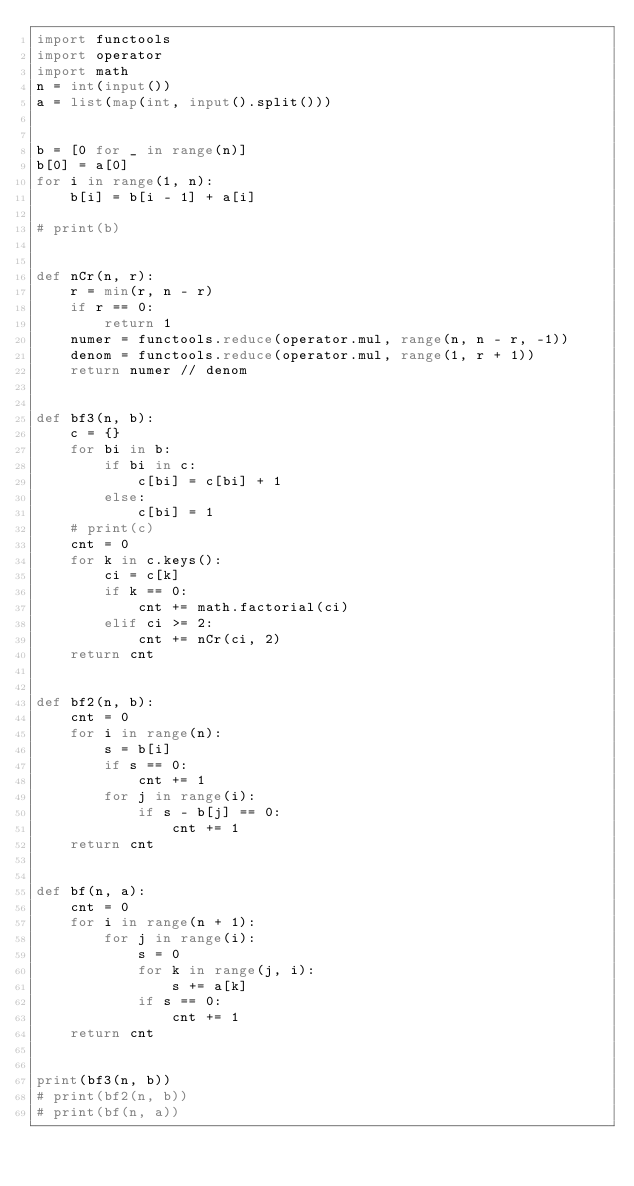<code> <loc_0><loc_0><loc_500><loc_500><_Python_>import functools
import operator
import math
n = int(input())
a = list(map(int, input().split()))


b = [0 for _ in range(n)]
b[0] = a[0]
for i in range(1, n):
    b[i] = b[i - 1] + a[i]

# print(b)


def nCr(n, r):
    r = min(r, n - r)
    if r == 0:
        return 1
    numer = functools.reduce(operator.mul, range(n, n - r, -1))
    denom = functools.reduce(operator.mul, range(1, r + 1))
    return numer // denom


def bf3(n, b):
    c = {}
    for bi in b:
        if bi in c:
            c[bi] = c[bi] + 1
        else:
            c[bi] = 1
    # print(c)
    cnt = 0
    for k in c.keys():
        ci = c[k]
        if k == 0:
            cnt += math.factorial(ci)
        elif ci >= 2:
            cnt += nCr(ci, 2)
    return cnt


def bf2(n, b):
    cnt = 0
    for i in range(n):
        s = b[i]
        if s == 0:
            cnt += 1
        for j in range(i):
            if s - b[j] == 0:
                cnt += 1
    return cnt


def bf(n, a):
    cnt = 0
    for i in range(n + 1):
        for j in range(i):
            s = 0
            for k in range(j, i):
                s += a[k]
            if s == 0:
                cnt += 1
    return cnt


print(bf3(n, b))
# print(bf2(n, b))
# print(bf(n, a))
</code> 